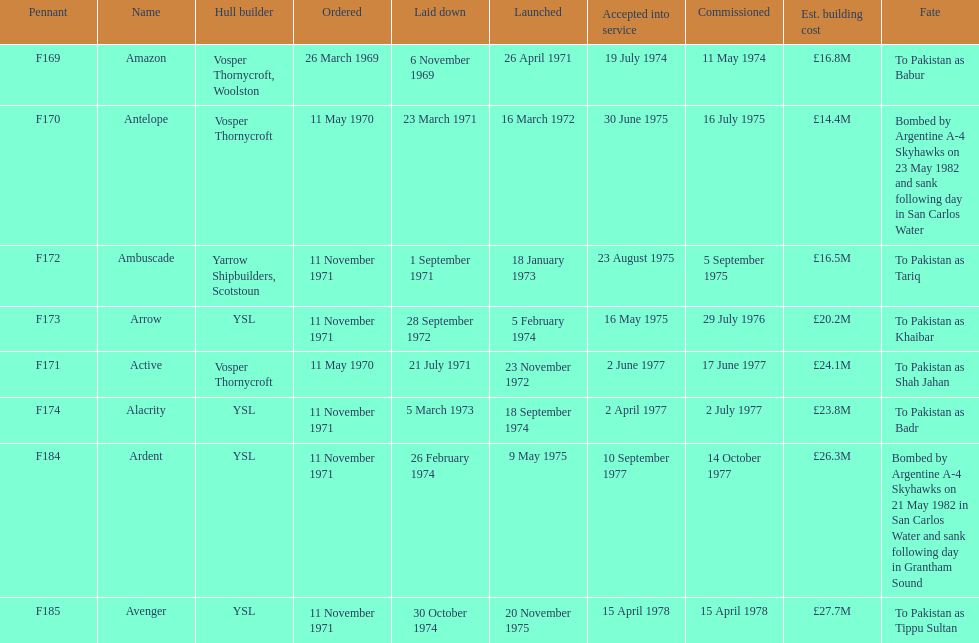What is the next pennant after f172? F173. 